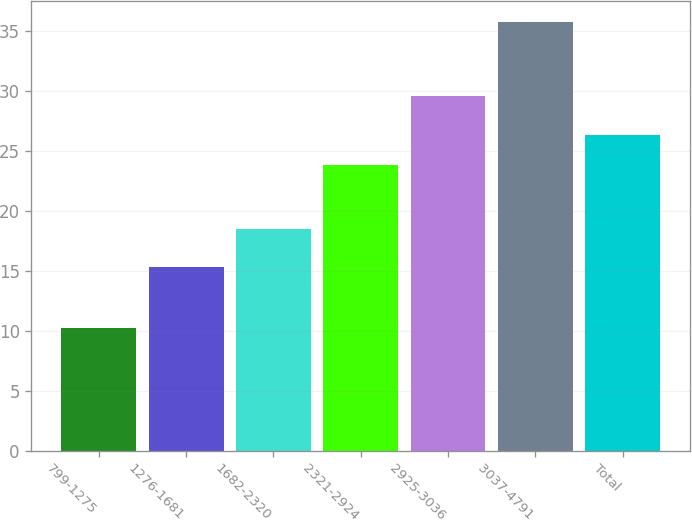Convert chart. <chart><loc_0><loc_0><loc_500><loc_500><bar_chart><fcel>799-1275<fcel>1276-1681<fcel>1682-2320<fcel>2321-2924<fcel>2925-3036<fcel>3037-4791<fcel>Total<nl><fcel>10.23<fcel>15.28<fcel>18.52<fcel>23.82<fcel>29.56<fcel>35.75<fcel>26.37<nl></chart> 